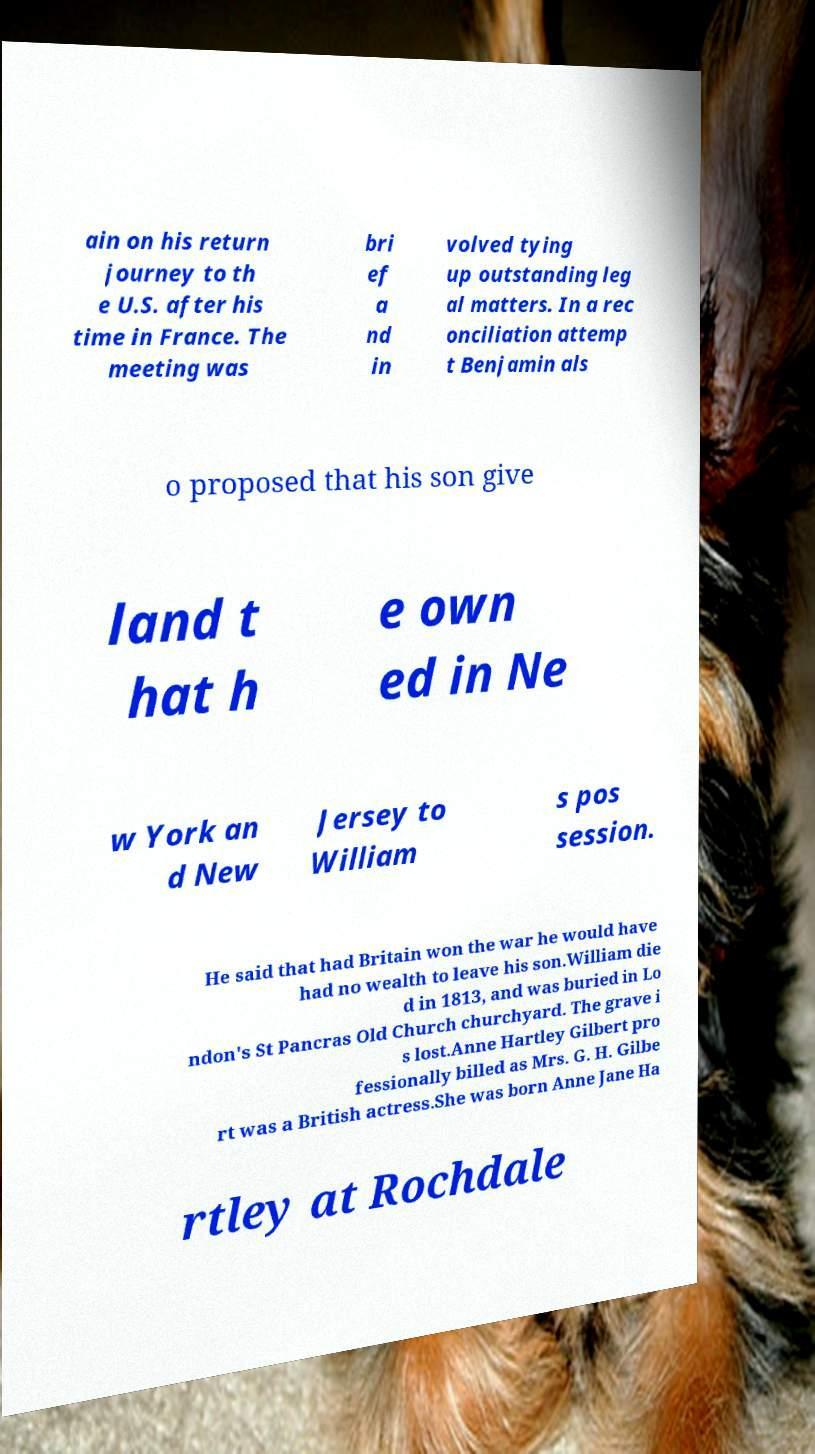Can you read and provide the text displayed in the image?This photo seems to have some interesting text. Can you extract and type it out for me? ain on his return journey to th e U.S. after his time in France. The meeting was bri ef a nd in volved tying up outstanding leg al matters. In a rec onciliation attemp t Benjamin als o proposed that his son give land t hat h e own ed in Ne w York an d New Jersey to William s pos session. He said that had Britain won the war he would have had no wealth to leave his son.William die d in 1813, and was buried in Lo ndon's St Pancras Old Church churchyard. The grave i s lost.Anne Hartley Gilbert pro fessionally billed as Mrs. G. H. Gilbe rt was a British actress.She was born Anne Jane Ha rtley at Rochdale 